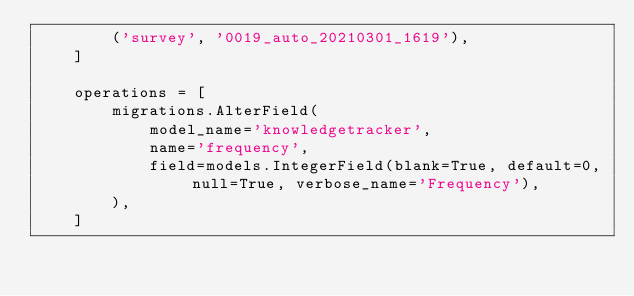<code> <loc_0><loc_0><loc_500><loc_500><_Python_>        ('survey', '0019_auto_20210301_1619'),
    ]

    operations = [
        migrations.AlterField(
            model_name='knowledgetracker',
            name='frequency',
            field=models.IntegerField(blank=True, default=0, null=True, verbose_name='Frequency'),
        ),
    ]
</code> 